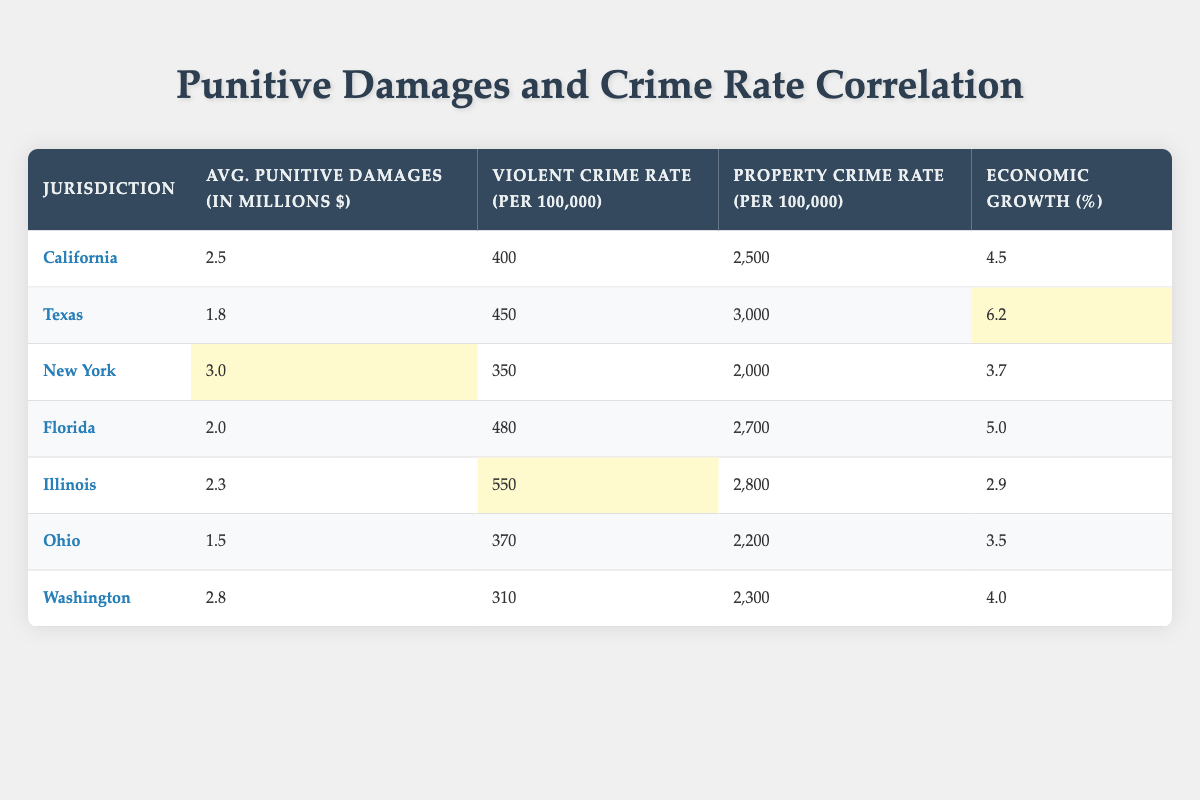What are the average punitive damages in California? The table shows that California has average punitive damages of 2.5 million dollars.
Answer: 2.5 million dollars Which jurisdiction has the highest property crime rate? By examining the property crime rates in the table, Illinois has the highest property crime rate of 2800 per 100,000.
Answer: Illinois What is the average economic growth of the jurisdictions listed? To find the average, sum the economic growth values: (4.5 + 6.2 + 3.7 + 5.0 + 2.9 + 3.5 + 4.0) = 30.8. Then, divide by 7 (the number of jurisdictions) to get the average: 30.8 / 7 = 4.4.
Answer: 4.4% Is Texas's average punitive damages lower than New York's? Texas's average punitive damages are 1.8 million dollars, while New York's are 3.0 million dollars. Therefore, the statement is true.
Answer: Yes Which state has a violent crime rate lower than 400? Looking through the table, only Washington has a violent crime rate of 310, which is below 400.
Answer: Washington What is the difference in average punitive damages between California and Florida? California's average punitive damages are 2.5 million dollars, and Florida's are 2.0 million dollars. The difference is 2.5 - 2.0 = 0.5 million dollars.
Answer: 0.5 million dollars Which jurisdiction has the lowest violent crime rate, and what is that rate? The table indicates that Washington has the lowest violent crime rate at 310 per 100,000.
Answer: Washington, 310 per 100,000 If you sort jurisdictions by average punitive damages, which comes third? Listing the jurisdictions by average punitive damages: New York (3.0), Washington (2.8), California (2.5), Illinois (2.3), Florida (2.0), Texas (1.8), Ohio (1.5). The third one is California at 2.5 million dollars.
Answer: California, 2.5 million dollars 